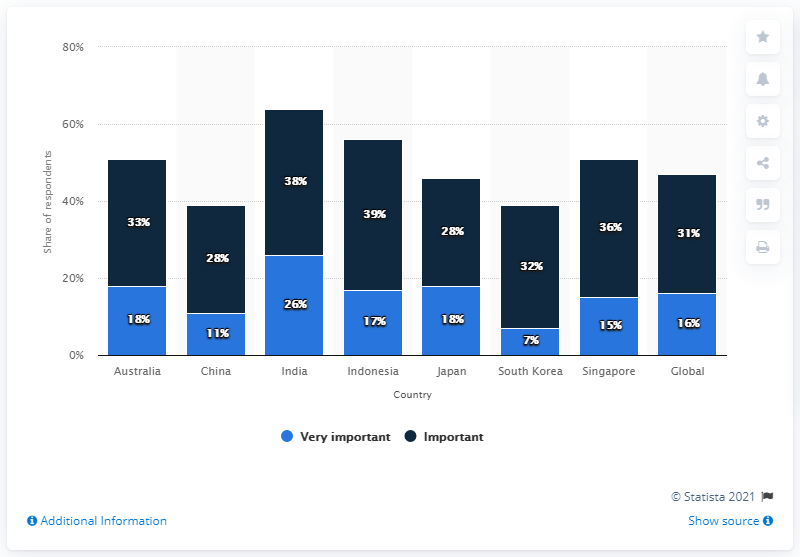List a handful of essential elements in this visual. According to the survey, 11% of Chinese consumers believe that simplifying their health and beauty regimen is crucial. 